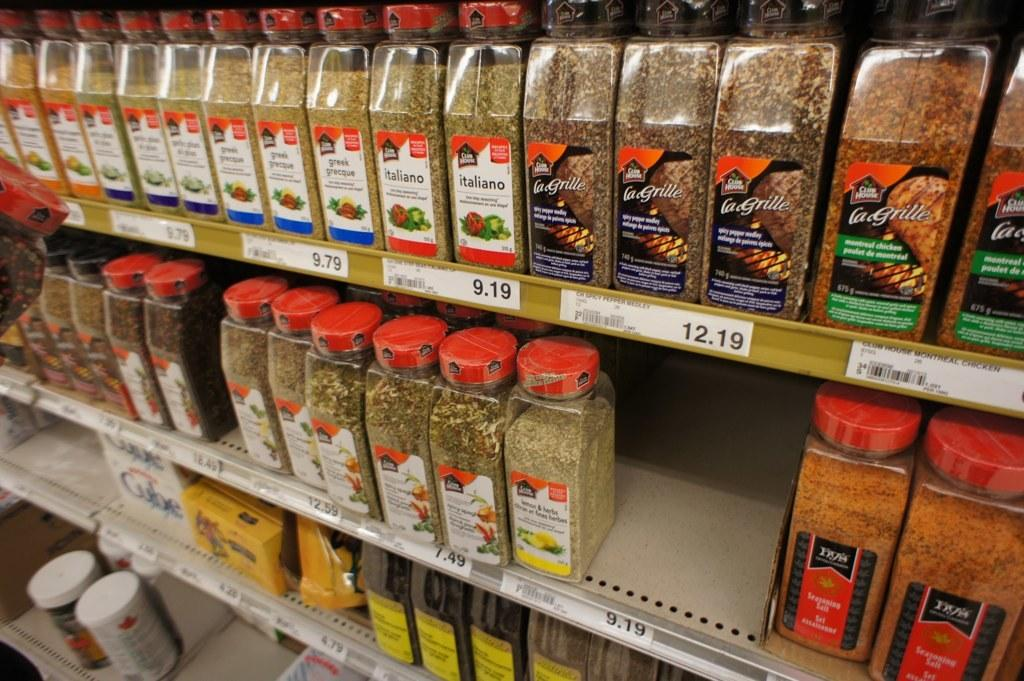Provide a one-sentence caption for the provided image. Spices displayed on a rack, some for 7.49 and others for 12.19. 